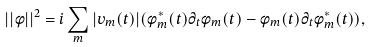<formula> <loc_0><loc_0><loc_500><loc_500>| | \phi | | ^ { 2 } = i \sum _ { m } | v _ { m } ( t ) | ( \phi ^ { * } _ { m } ( t ) \partial _ { t } \phi _ { m } ( t ) - \phi _ { m } ( t ) \partial _ { t } \phi ^ { * } _ { m } ( t ) ) ,</formula> 